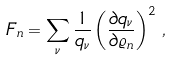<formula> <loc_0><loc_0><loc_500><loc_500>F _ { n } = \sum _ { \nu } \frac { 1 } { q _ { \nu } } \left ( \frac { \partial q _ { \nu } } { \partial \varrho _ { n } } \right ) ^ { 2 } \, ,</formula> 